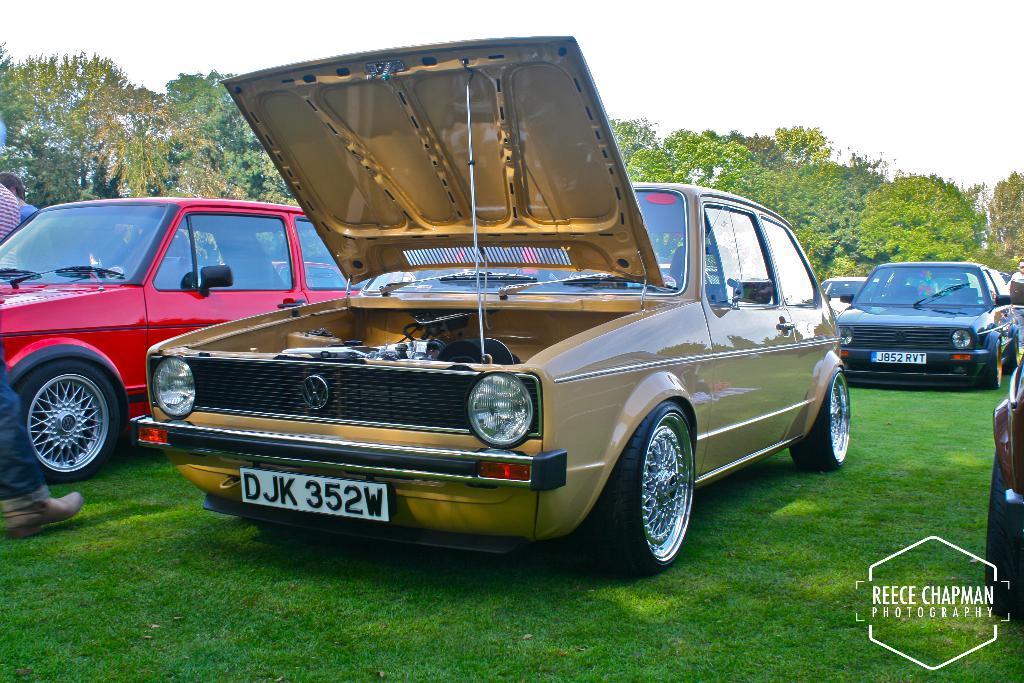Please provide a concise description of this image. In this picture we can observe some cars parked on the ground. There is some grass on the ground. We can observe brown, red and black color cars. There is watermark on the right side. In the background there are trees and a sky. 